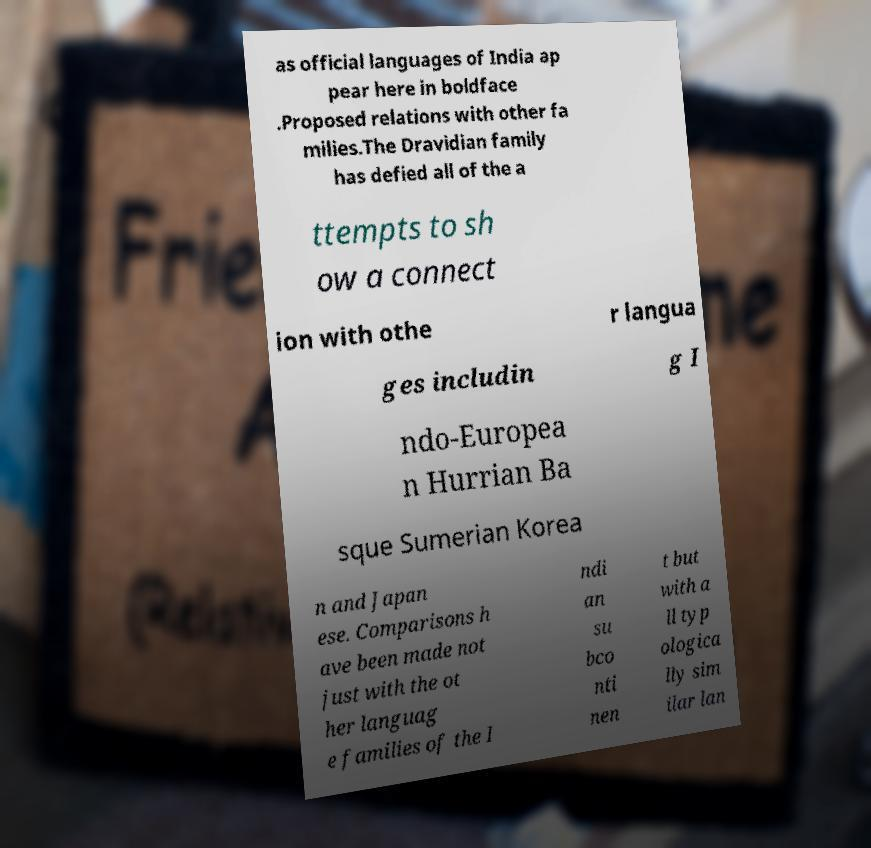For documentation purposes, I need the text within this image transcribed. Could you provide that? as official languages of India ap pear here in boldface .Proposed relations with other fa milies.The Dravidian family has defied all of the a ttempts to sh ow a connect ion with othe r langua ges includin g I ndo-Europea n Hurrian Ba sque Sumerian Korea n and Japan ese. Comparisons h ave been made not just with the ot her languag e families of the I ndi an su bco nti nen t but with a ll typ ologica lly sim ilar lan 